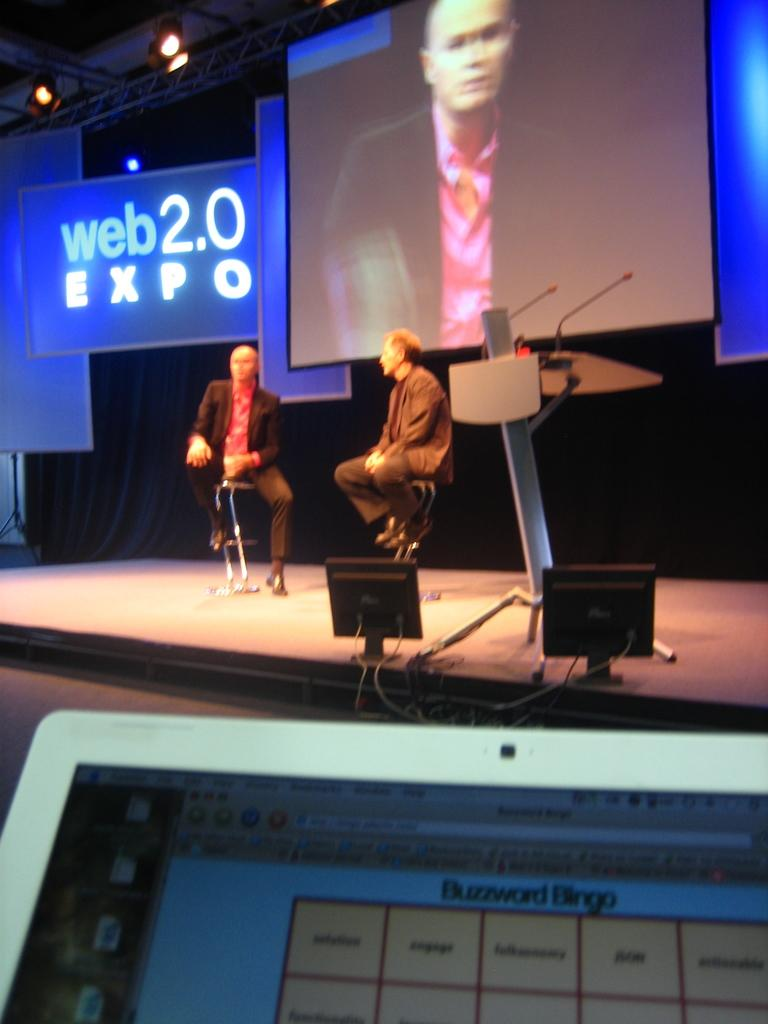<image>
Relay a brief, clear account of the picture shown. Two men are seated on a stage with a large screen behind them and another to the side that says web 2.0 Expo. 